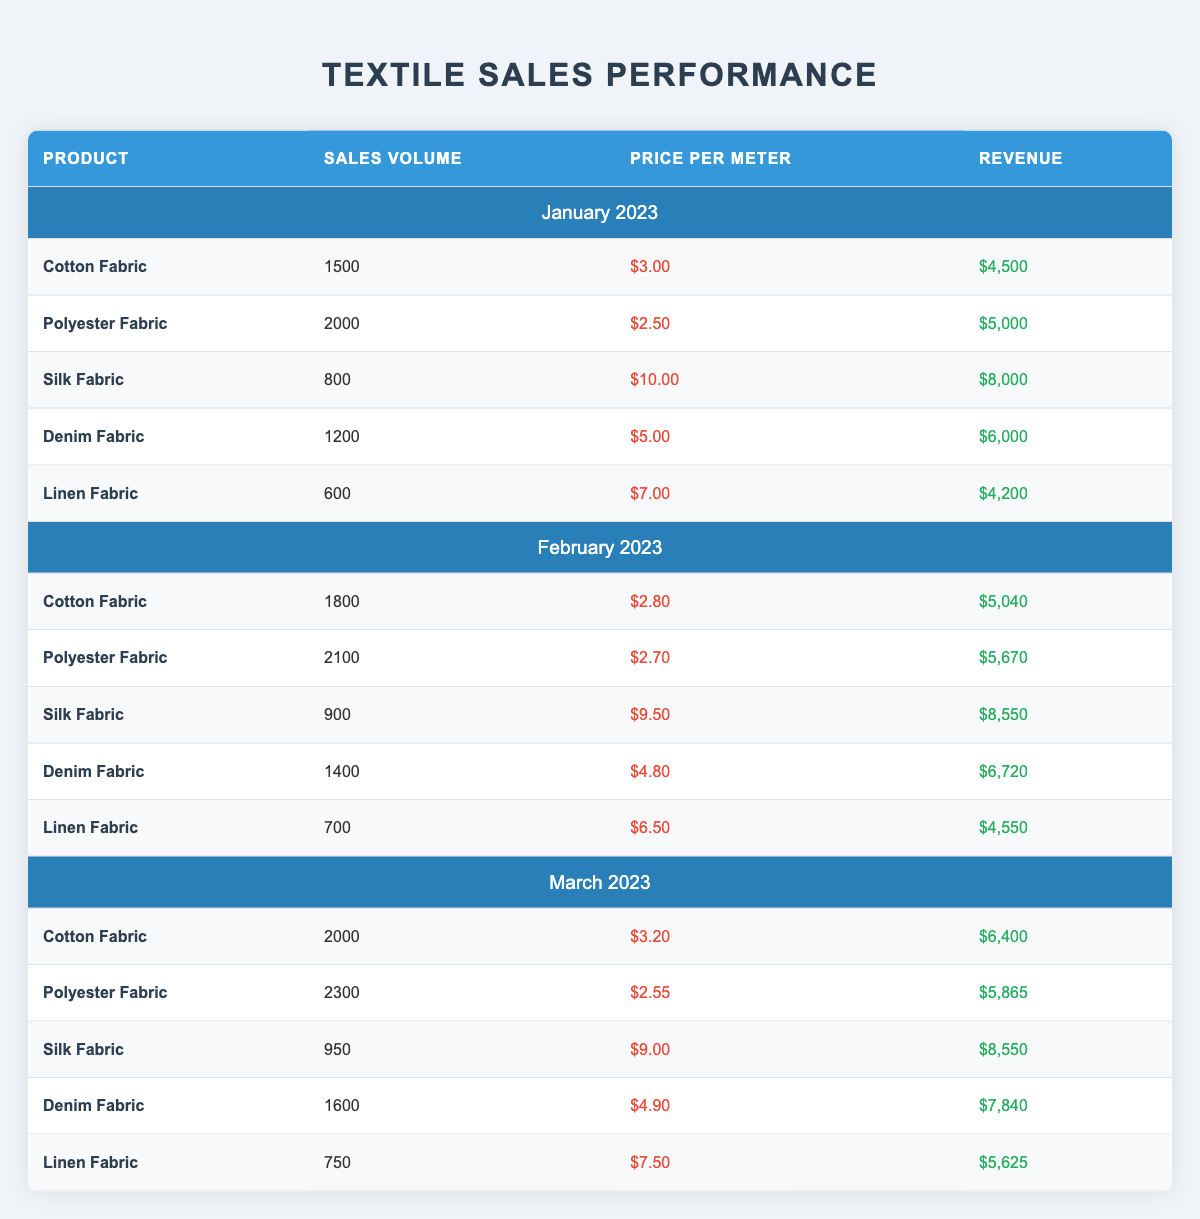What was the revenue from Silk Fabric in March 2023? The table shows that in March 2023 the revenue from Silk Fabric is listed as $8,550.
Answer: $8,550 Which product had the highest sales volume in January 2023? From the table, the product with the highest sales volume in January 2023 is Polyester Fabric with a sales volume of 2,000.
Answer: Polyester Fabric What is the average price per meter of Denim Fabric across the three months? First, we look at the price per meter of Denim Fabric for each month: January $5.00, February $4.80, March $4.90. Adding these gives 5.00 + 4.80 + 4.90 = 14.70. Then we divide by the number of months (3): 14.70 / 3 = 4.90.
Answer: $4.90 Did Linen Fabric have a higher sales volume in February or March 2023? In February 2023, the sales volume for Linen Fabric is 700, and in March 2023, it is 750. Since 750 (March) is greater than 700 (February), Linen Fabric had a higher sales volume in March 2023.
Answer: Yes What is the total revenue from Cotton Fabric over the three months? We need to sum the revenues from Cotton Fabric in January ($4,500), February ($5,040), and March ($6,400). Adding these amounts: 4,500 + 5,040 + 6,400 = 15,940.
Answer: $15,940 Which month showed the highest overall revenue from Polyester Fabric? The revenues from Polyester Fabric are January: $5,000, February: $5,670, and March: $5,865. Comparing these values, February shows the highest revenue with $5,670.
Answer: February 2023 Was the sales volume of Cotton Fabric in January greater than 1,600? The table indicates that the sales volume of Cotton Fabric in January 2023 is 1,500, which is not greater than 1,600.
Answer: No How much more revenue did Silk Fabric generate compared to Linen Fabric in February 2023? For February 2023, Silk Fabric generated $8,550 in revenue, while Linen Fabric generated $4,550. To find the difference, we calculate 8,550 - 4,550 = 4,000.
Answer: $4,000 